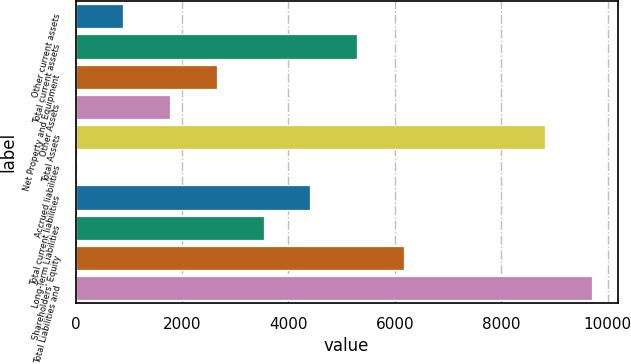Convert chart. <chart><loc_0><loc_0><loc_500><loc_500><bar_chart><fcel>Other current assets<fcel>Total current assets<fcel>Net Property and Equipment<fcel>Other Assets<fcel>Total Assets<fcel>Accrued liabilities<fcel>Total current liabilities<fcel>Long-Term Liabilities<fcel>Shareholders' Equity<fcel>Total Liabilities and<nl><fcel>888.7<fcel>5297.2<fcel>2652.1<fcel>1770.4<fcel>8824<fcel>7<fcel>4415.5<fcel>3533.8<fcel>6178.9<fcel>9705.7<nl></chart> 